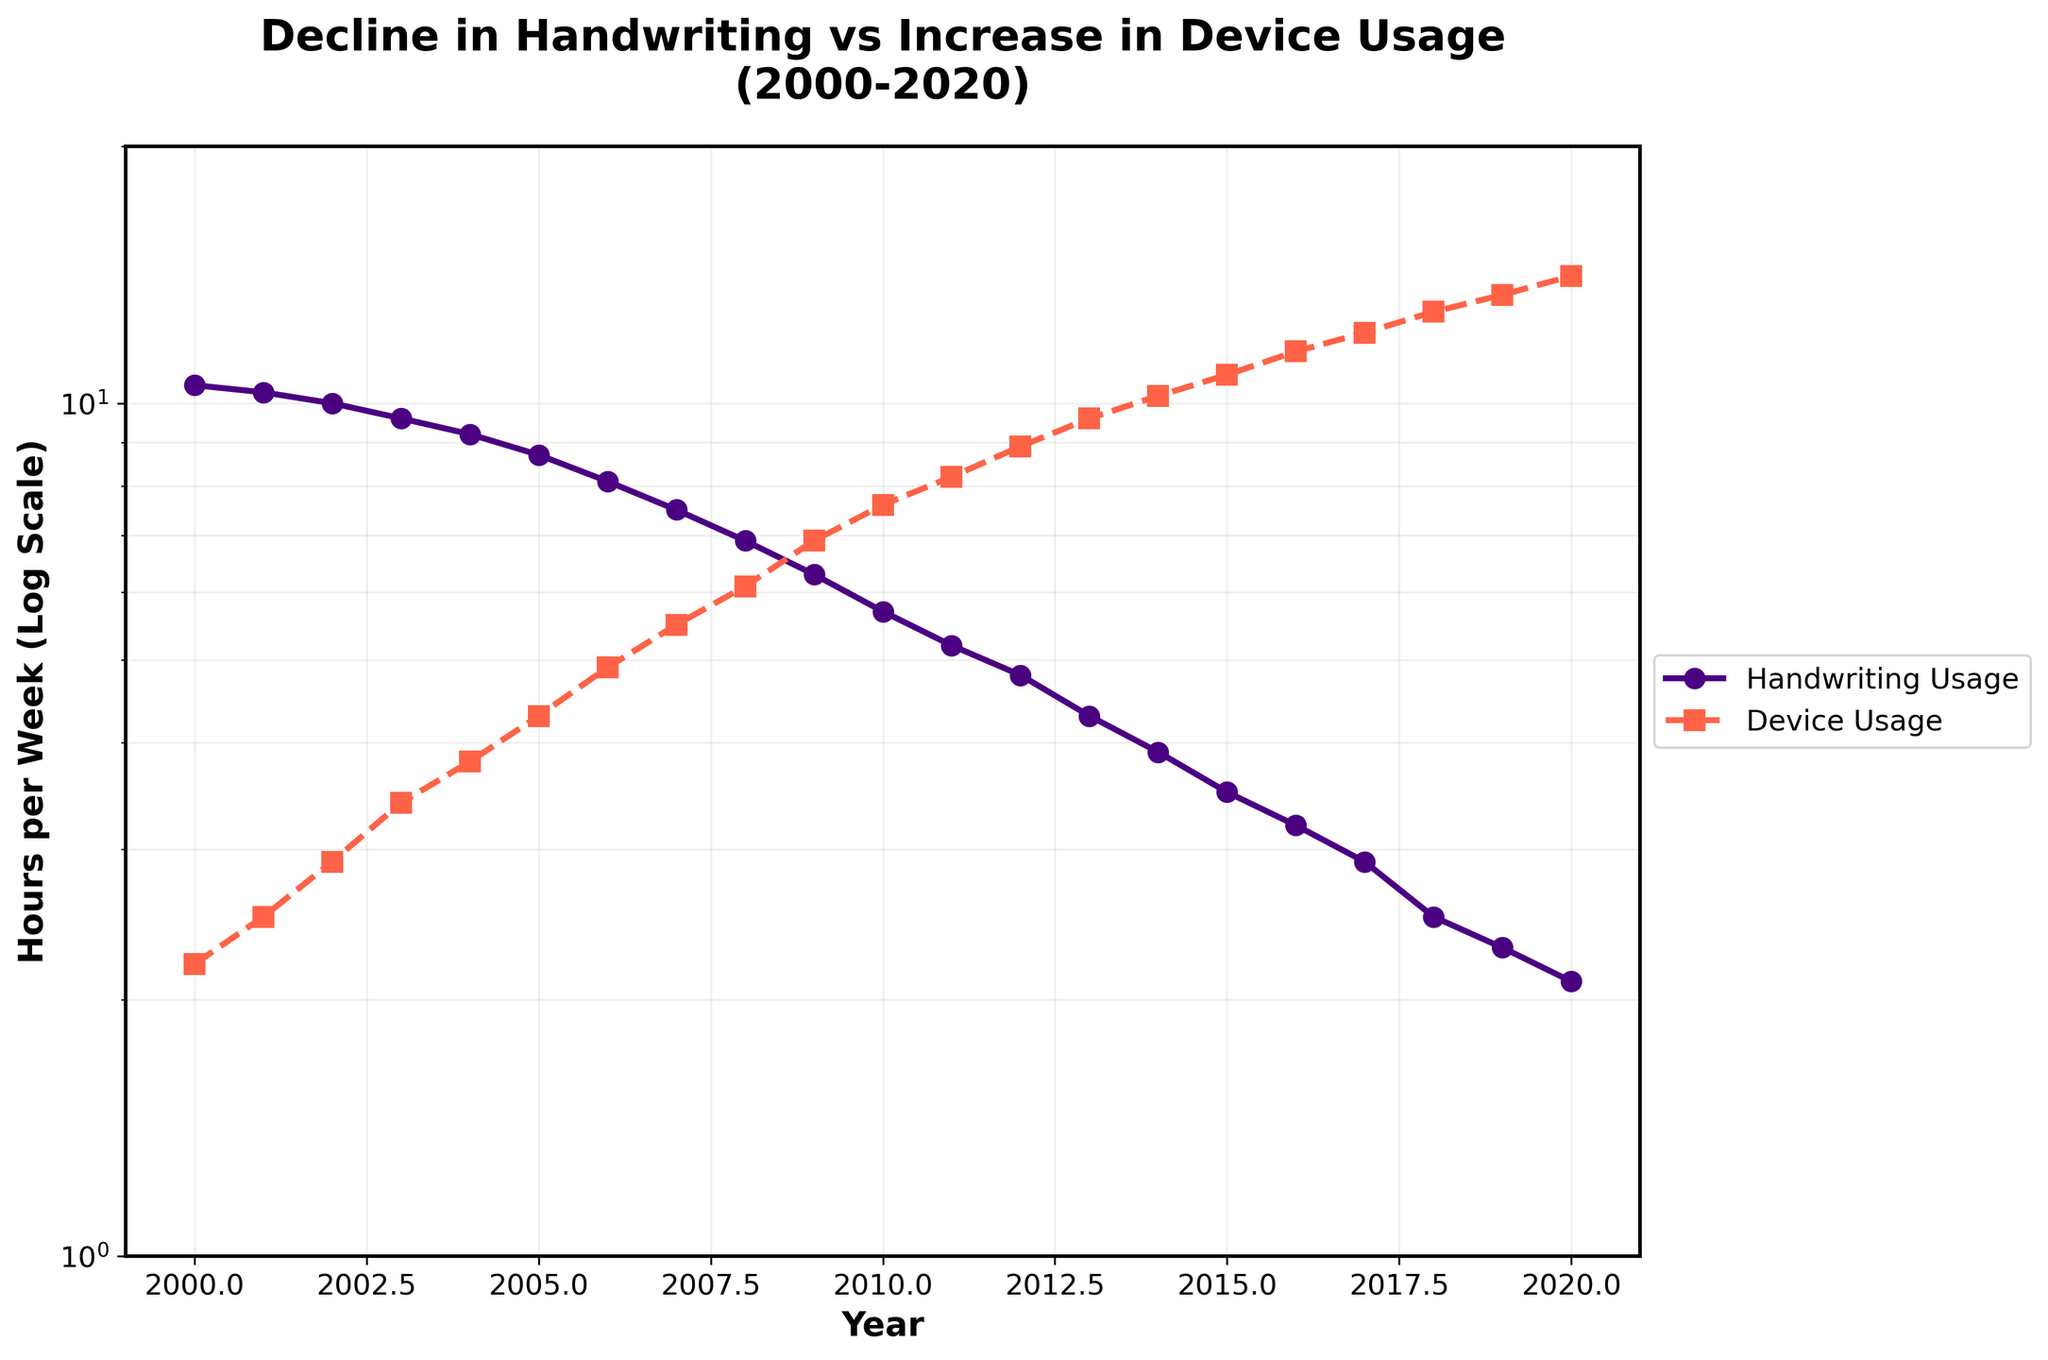What's the title of the plot? The title is prominently displayed at the top of the plot.
Answer: Decline in Handwriting vs Increase in Device Usage (2000-2020) How many data points are represented for each line? There are data points for each year from 2000 to 2020, making a total of 21 data points per line.
Answer: 21 Which year marks the first time Handwriting Usage falls below 5 hours per week? Locate the point on the Handwriting Usage line and note the corresponding year.
Answer: 2011 By approximately how many hours did Device Usage increase from 2000 to 2020? Subtract Device Usage hours in 2000 from those in 2020. 14.1 - 2.2 = 11.9
Answer: 11.9 hours Is the decline in Handwriting Usage consistent over the years 2000 to 2020? Observe the Handwriting Usage line to see if it continuously drops each year.
Answer: Yes Is the growth in Device Usage more or less steep compared to the decline in Handwriting Usage? Compare the slope or steepness of both lines over the years. The Device Usage increases at a faster rate than the decline in Handwriting Usage.
Answer: More steep Which year saw Handwriting Usage drop to half its 2000 value? First, find half of the 2000 value (10.5/2 = 5.25). Then, find the year when Handwriting Usage is first below 5.25.
Answer: 2011 When did Device Usage first reach 10 hours per week? Check the data points on the Device Usage line and find the year when it first equals or exceeds 10 hours.
Answer: 2014 How does the y-axis in this plot differ from a standard linear plot? Notice that the y-axis uses a logarithmic scale instead of a linear one; it is indicated by the scaling of the tick marks.
Answer: Logarithmic scale 